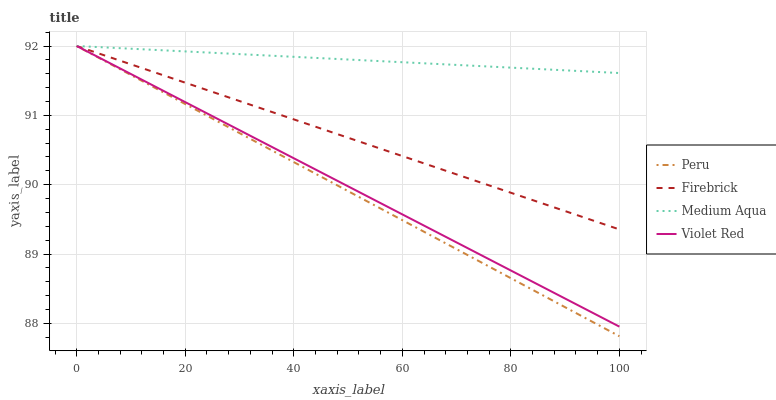Does Peru have the minimum area under the curve?
Answer yes or no. Yes. Does Medium Aqua have the maximum area under the curve?
Answer yes or no. Yes. Does Violet Red have the minimum area under the curve?
Answer yes or no. No. Does Violet Red have the maximum area under the curve?
Answer yes or no. No. Is Medium Aqua the smoothest?
Answer yes or no. Yes. Is Firebrick the roughest?
Answer yes or no. Yes. Is Violet Red the smoothest?
Answer yes or no. No. Is Violet Red the roughest?
Answer yes or no. No. Does Peru have the lowest value?
Answer yes or no. Yes. Does Violet Red have the lowest value?
Answer yes or no. No. Does Peru have the highest value?
Answer yes or no. Yes. Does Peru intersect Medium Aqua?
Answer yes or no. Yes. Is Peru less than Medium Aqua?
Answer yes or no. No. Is Peru greater than Medium Aqua?
Answer yes or no. No. 